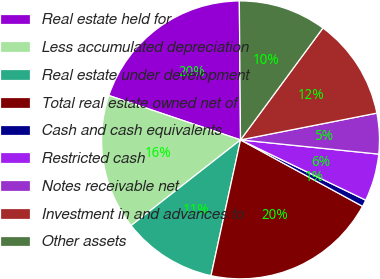<chart> <loc_0><loc_0><loc_500><loc_500><pie_chart><fcel>Real estate held for<fcel>Less accumulated depreciation<fcel>Real estate under development<fcel>Total real estate owned net of<fcel>Cash and cash equivalents<fcel>Restricted cash<fcel>Notes receivable net<fcel>Investment in and advances to<fcel>Other assets<nl><fcel>19.69%<fcel>15.75%<fcel>11.02%<fcel>20.47%<fcel>0.79%<fcel>5.51%<fcel>4.72%<fcel>11.81%<fcel>10.24%<nl></chart> 